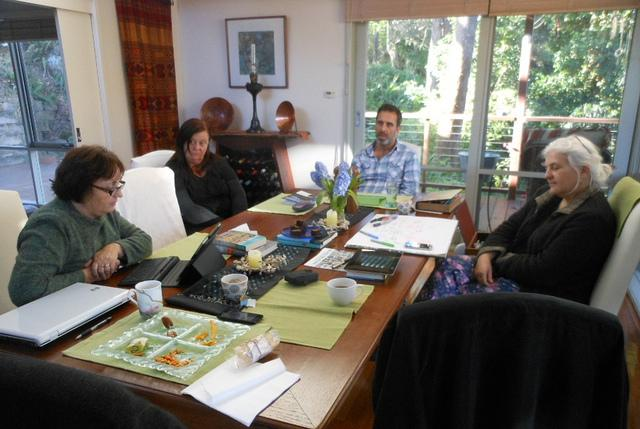What kind of gathering is this? business meeting 